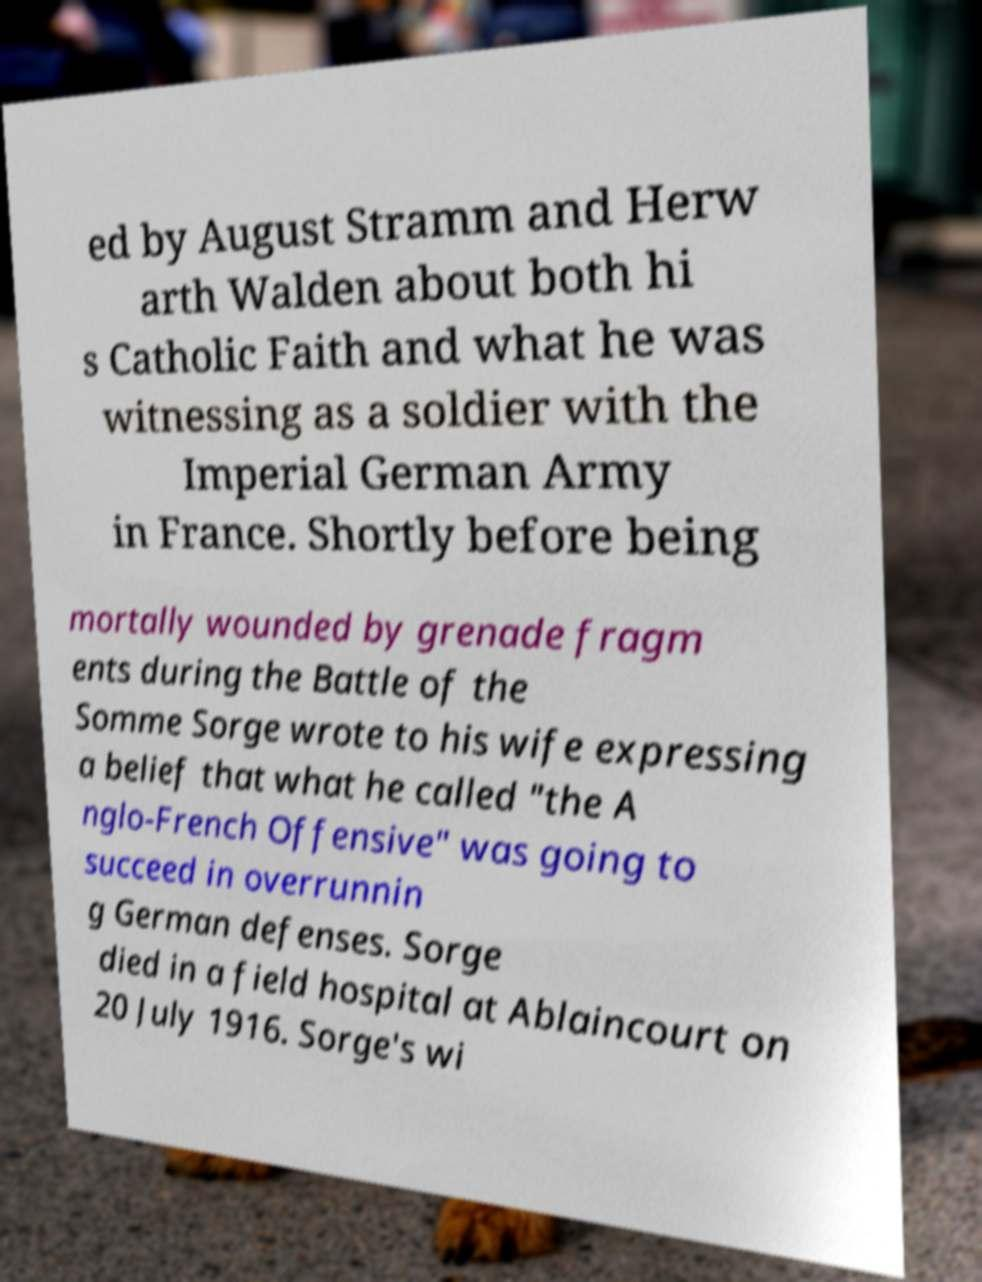For documentation purposes, I need the text within this image transcribed. Could you provide that? ed by August Stramm and Herw arth Walden about both hi s Catholic Faith and what he was witnessing as a soldier with the Imperial German Army in France. Shortly before being mortally wounded by grenade fragm ents during the Battle of the Somme Sorge wrote to his wife expressing a belief that what he called "the A nglo-French Offensive" was going to succeed in overrunnin g German defenses. Sorge died in a field hospital at Ablaincourt on 20 July 1916. Sorge's wi 